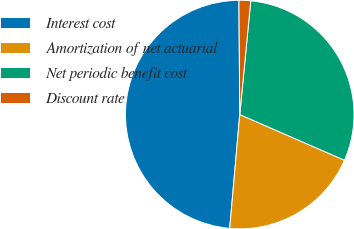<chart> <loc_0><loc_0><loc_500><loc_500><pie_chart><fcel>Interest cost<fcel>Amortization of net actuarial<fcel>Net periodic benefit cost<fcel>Discount rate<nl><fcel>48.48%<fcel>19.85%<fcel>30.01%<fcel>1.65%<nl></chart> 